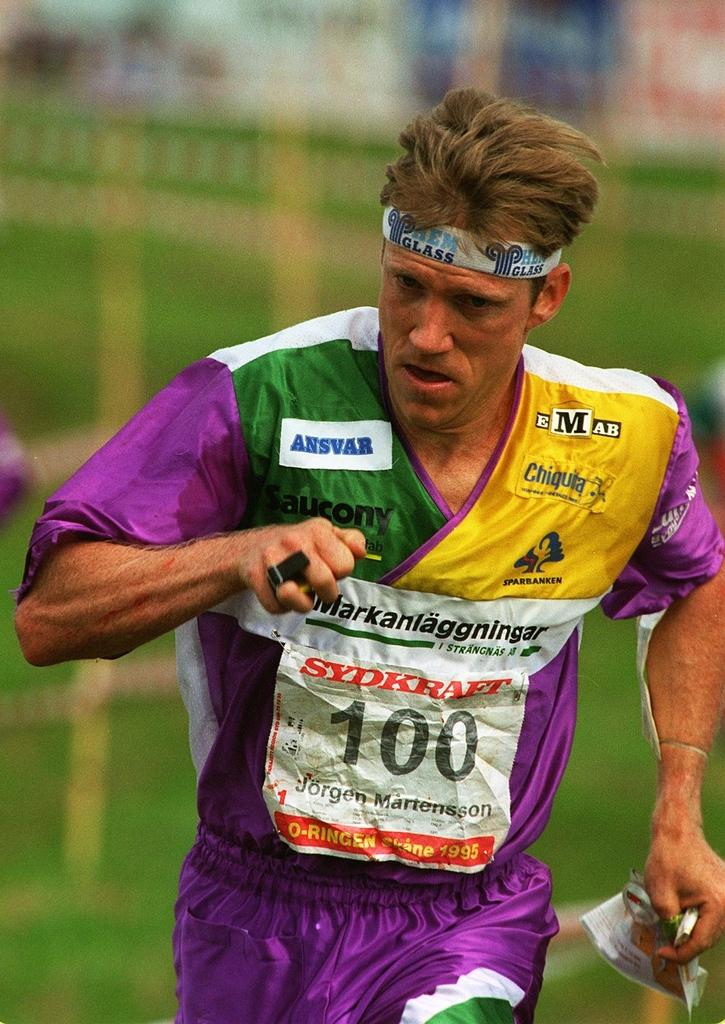What can be seen in the image? There is a person in the image. What is the person wearing? The person is wearing a colorful t-shirt. What is on the person's head? The person has a band on his head. What is the person holding? The person is holding a paper. What is the person's mouth doing? The person's mouth is open. What is the taste of the silver in the image? There is no silver present in the image, so it is not possible to determine its taste. 